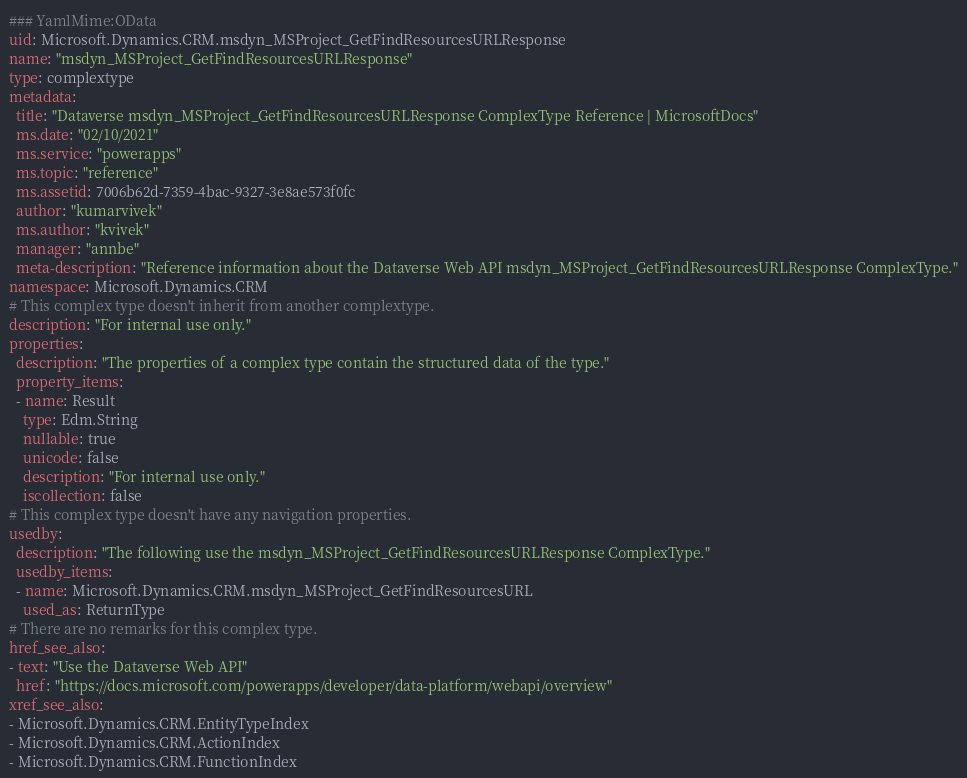<code> <loc_0><loc_0><loc_500><loc_500><_YAML_>### YamlMime:OData
uid: Microsoft.Dynamics.CRM.msdyn_MSProject_GetFindResourcesURLResponse
name: "msdyn_MSProject_GetFindResourcesURLResponse"
type: complextype
metadata: 
  title: "Dataverse msdyn_MSProject_GetFindResourcesURLResponse ComplexType Reference | MicrosoftDocs"
  ms.date: "02/10/2021"
  ms.service: "powerapps"
  ms.topic: "reference"
  ms.assetid: 7006b62d-7359-4bac-9327-3e8ae573f0fc
  author: "kumarvivek"
  ms.author: "kvivek"
  manager: "annbe"
  meta-description: "Reference information about the Dataverse Web API msdyn_MSProject_GetFindResourcesURLResponse ComplexType."
namespace: Microsoft.Dynamics.CRM
# This complex type doesn't inherit from another complextype.
description: "For internal use only." 
properties:
  description: "The properties of a complex type contain the structured data of the type."
  property_items:
  - name: Result
    type: Edm.String
    nullable: true
    unicode: false
    description: "For internal use only."
    iscollection: false
# This complex type doesn't have any navigation properties.
usedby:
  description: "The following use the msdyn_MSProject_GetFindResourcesURLResponse ComplexType."
  usedby_items:
  - name: Microsoft.Dynamics.CRM.msdyn_MSProject_GetFindResourcesURL
    used_as: ReturnType
# There are no remarks for this complex type.
href_see_also:
- text: "Use the Dataverse Web API"
  href: "https://docs.microsoft.com/powerapps/developer/data-platform/webapi/overview"
xref_see_also:
- Microsoft.Dynamics.CRM.EntityTypeIndex
- Microsoft.Dynamics.CRM.ActionIndex
- Microsoft.Dynamics.CRM.FunctionIndex</code> 